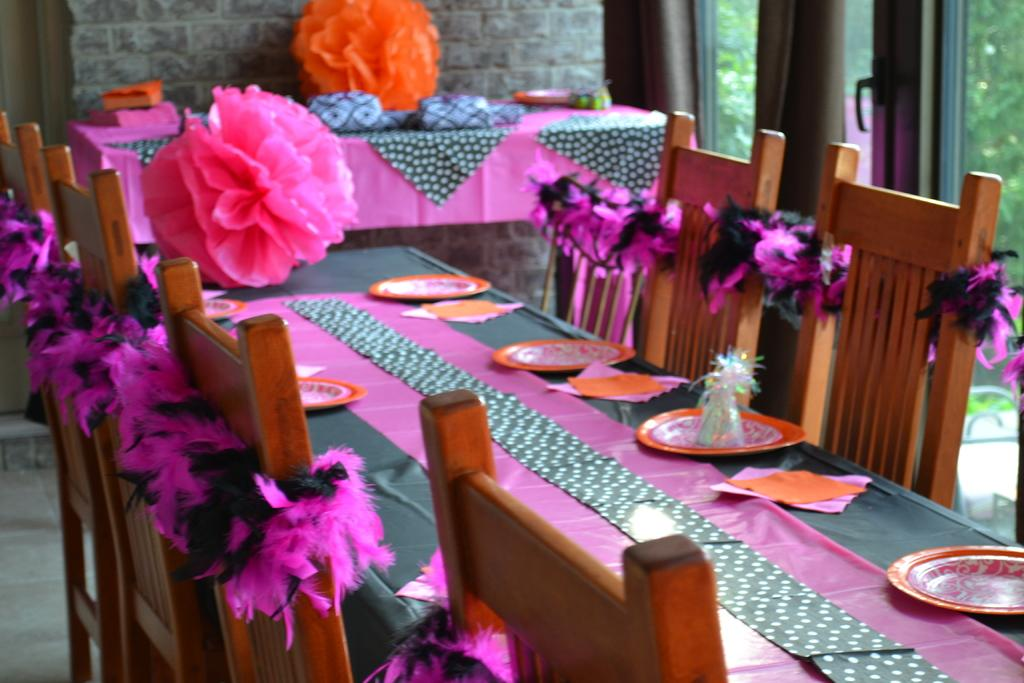What type of furniture is visible in the image? There are chairs with decorations in the image. What other type of furniture is present in the image? There are tables in the image. What items can be seen on the tables? Plates and tissues are present on the tables. What can be seen in the background of the image? There is a wall visible in the background of the image. Can you tell me how many umbrellas are open in the image? There are no umbrellas present in the image. What type of light source is illuminating the scene in the image? The provided facts do not mention any light source, so we cannot determine the type of light source in the image. 